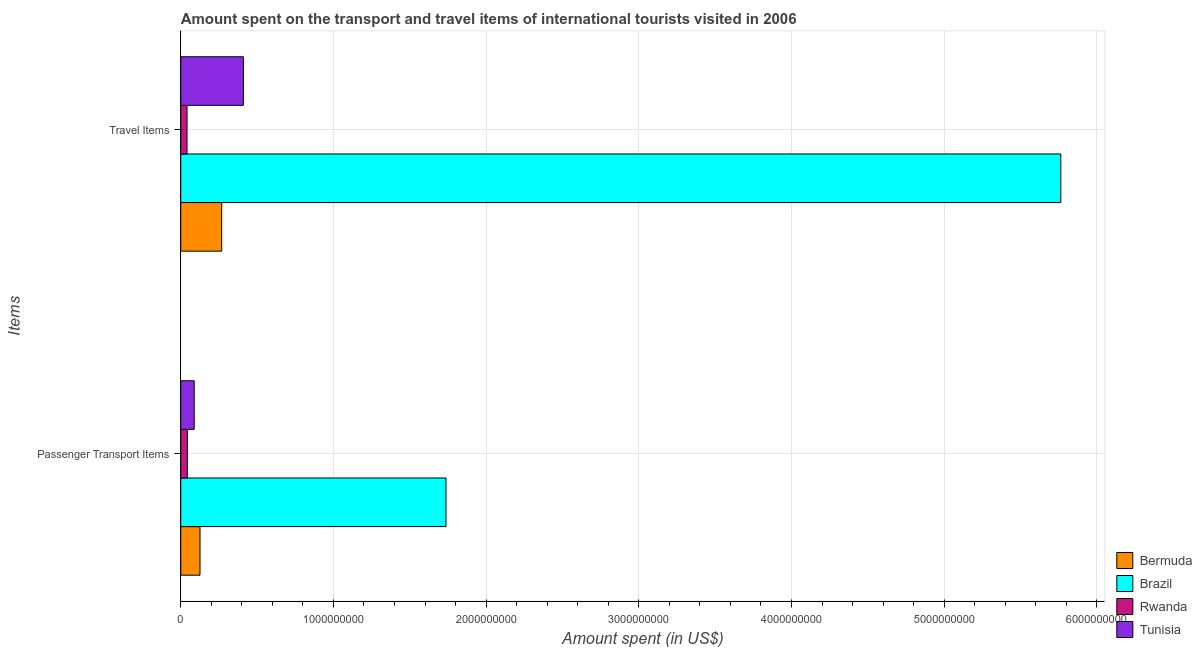How many different coloured bars are there?
Keep it short and to the point. 4. Are the number of bars per tick equal to the number of legend labels?
Give a very brief answer. Yes. Are the number of bars on each tick of the Y-axis equal?
Your answer should be compact. Yes. How many bars are there on the 1st tick from the top?
Ensure brevity in your answer.  4. What is the label of the 2nd group of bars from the top?
Provide a short and direct response. Passenger Transport Items. What is the amount spent in travel items in Bermuda?
Your answer should be compact. 2.68e+08. Across all countries, what is the maximum amount spent in travel items?
Keep it short and to the point. 5.76e+09. Across all countries, what is the minimum amount spent on passenger transport items?
Your answer should be compact. 4.30e+07. In which country was the amount spent on passenger transport items maximum?
Ensure brevity in your answer.  Brazil. In which country was the amount spent on passenger transport items minimum?
Make the answer very short. Rwanda. What is the total amount spent in travel items in the graph?
Offer a terse response. 6.48e+09. What is the difference between the amount spent on passenger transport items in Brazil and that in Rwanda?
Your answer should be very brief. 1.69e+09. What is the difference between the amount spent on passenger transport items in Tunisia and the amount spent in travel items in Brazil?
Provide a short and direct response. -5.68e+09. What is the average amount spent in travel items per country?
Your answer should be very brief. 1.62e+09. What is the difference between the amount spent on passenger transport items and amount spent in travel items in Rwanda?
Offer a terse response. 2.00e+06. What is the ratio of the amount spent in travel items in Bermuda to that in Brazil?
Keep it short and to the point. 0.05. In how many countries, is the amount spent on passenger transport items greater than the average amount spent on passenger transport items taken over all countries?
Offer a terse response. 1. What does the 4th bar from the top in Travel Items represents?
Make the answer very short. Bermuda. What does the 4th bar from the bottom in Travel Items represents?
Your answer should be compact. Tunisia. How many bars are there?
Provide a short and direct response. 8. Are the values on the major ticks of X-axis written in scientific E-notation?
Keep it short and to the point. No. Does the graph contain grids?
Provide a succinct answer. Yes. Where does the legend appear in the graph?
Offer a terse response. Bottom right. How many legend labels are there?
Provide a succinct answer. 4. What is the title of the graph?
Give a very brief answer. Amount spent on the transport and travel items of international tourists visited in 2006. Does "Montenegro" appear as one of the legend labels in the graph?
Make the answer very short. No. What is the label or title of the X-axis?
Ensure brevity in your answer.  Amount spent (in US$). What is the label or title of the Y-axis?
Ensure brevity in your answer.  Items. What is the Amount spent (in US$) of Bermuda in Passenger Transport Items?
Your response must be concise. 1.26e+08. What is the Amount spent (in US$) in Brazil in Passenger Transport Items?
Your response must be concise. 1.74e+09. What is the Amount spent (in US$) of Rwanda in Passenger Transport Items?
Provide a short and direct response. 4.30e+07. What is the Amount spent (in US$) in Tunisia in Passenger Transport Items?
Keep it short and to the point. 8.80e+07. What is the Amount spent (in US$) in Bermuda in Travel Items?
Provide a short and direct response. 2.68e+08. What is the Amount spent (in US$) in Brazil in Travel Items?
Ensure brevity in your answer.  5.76e+09. What is the Amount spent (in US$) of Rwanda in Travel Items?
Provide a succinct answer. 4.10e+07. What is the Amount spent (in US$) of Tunisia in Travel Items?
Your response must be concise. 4.10e+08. Across all Items, what is the maximum Amount spent (in US$) in Bermuda?
Ensure brevity in your answer.  2.68e+08. Across all Items, what is the maximum Amount spent (in US$) in Brazil?
Provide a short and direct response. 5.76e+09. Across all Items, what is the maximum Amount spent (in US$) in Rwanda?
Keep it short and to the point. 4.30e+07. Across all Items, what is the maximum Amount spent (in US$) of Tunisia?
Give a very brief answer. 4.10e+08. Across all Items, what is the minimum Amount spent (in US$) in Bermuda?
Offer a terse response. 1.26e+08. Across all Items, what is the minimum Amount spent (in US$) in Brazil?
Ensure brevity in your answer.  1.74e+09. Across all Items, what is the minimum Amount spent (in US$) of Rwanda?
Offer a terse response. 4.10e+07. Across all Items, what is the minimum Amount spent (in US$) of Tunisia?
Give a very brief answer. 8.80e+07. What is the total Amount spent (in US$) in Bermuda in the graph?
Your answer should be compact. 3.94e+08. What is the total Amount spent (in US$) of Brazil in the graph?
Offer a very short reply. 7.50e+09. What is the total Amount spent (in US$) of Rwanda in the graph?
Your answer should be very brief. 8.40e+07. What is the total Amount spent (in US$) of Tunisia in the graph?
Provide a succinct answer. 4.98e+08. What is the difference between the Amount spent (in US$) of Bermuda in Passenger Transport Items and that in Travel Items?
Your answer should be compact. -1.42e+08. What is the difference between the Amount spent (in US$) in Brazil in Passenger Transport Items and that in Travel Items?
Your answer should be very brief. -4.03e+09. What is the difference between the Amount spent (in US$) in Tunisia in Passenger Transport Items and that in Travel Items?
Provide a succinct answer. -3.22e+08. What is the difference between the Amount spent (in US$) in Bermuda in Passenger Transport Items and the Amount spent (in US$) in Brazil in Travel Items?
Keep it short and to the point. -5.64e+09. What is the difference between the Amount spent (in US$) in Bermuda in Passenger Transport Items and the Amount spent (in US$) in Rwanda in Travel Items?
Your answer should be very brief. 8.50e+07. What is the difference between the Amount spent (in US$) of Bermuda in Passenger Transport Items and the Amount spent (in US$) of Tunisia in Travel Items?
Ensure brevity in your answer.  -2.84e+08. What is the difference between the Amount spent (in US$) of Brazil in Passenger Transport Items and the Amount spent (in US$) of Rwanda in Travel Items?
Keep it short and to the point. 1.70e+09. What is the difference between the Amount spent (in US$) in Brazil in Passenger Transport Items and the Amount spent (in US$) in Tunisia in Travel Items?
Ensure brevity in your answer.  1.33e+09. What is the difference between the Amount spent (in US$) in Rwanda in Passenger Transport Items and the Amount spent (in US$) in Tunisia in Travel Items?
Provide a succinct answer. -3.67e+08. What is the average Amount spent (in US$) in Bermuda per Items?
Ensure brevity in your answer.  1.97e+08. What is the average Amount spent (in US$) in Brazil per Items?
Give a very brief answer. 3.75e+09. What is the average Amount spent (in US$) in Rwanda per Items?
Keep it short and to the point. 4.20e+07. What is the average Amount spent (in US$) of Tunisia per Items?
Keep it short and to the point. 2.49e+08. What is the difference between the Amount spent (in US$) in Bermuda and Amount spent (in US$) in Brazil in Passenger Transport Items?
Your response must be concise. -1.61e+09. What is the difference between the Amount spent (in US$) of Bermuda and Amount spent (in US$) of Rwanda in Passenger Transport Items?
Make the answer very short. 8.30e+07. What is the difference between the Amount spent (in US$) in Bermuda and Amount spent (in US$) in Tunisia in Passenger Transport Items?
Keep it short and to the point. 3.80e+07. What is the difference between the Amount spent (in US$) in Brazil and Amount spent (in US$) in Rwanda in Passenger Transport Items?
Your answer should be very brief. 1.69e+09. What is the difference between the Amount spent (in US$) in Brazil and Amount spent (in US$) in Tunisia in Passenger Transport Items?
Offer a very short reply. 1.65e+09. What is the difference between the Amount spent (in US$) in Rwanda and Amount spent (in US$) in Tunisia in Passenger Transport Items?
Offer a terse response. -4.50e+07. What is the difference between the Amount spent (in US$) in Bermuda and Amount spent (in US$) in Brazil in Travel Items?
Your answer should be very brief. -5.50e+09. What is the difference between the Amount spent (in US$) in Bermuda and Amount spent (in US$) in Rwanda in Travel Items?
Your answer should be compact. 2.27e+08. What is the difference between the Amount spent (in US$) in Bermuda and Amount spent (in US$) in Tunisia in Travel Items?
Give a very brief answer. -1.42e+08. What is the difference between the Amount spent (in US$) of Brazil and Amount spent (in US$) of Rwanda in Travel Items?
Offer a terse response. 5.72e+09. What is the difference between the Amount spent (in US$) of Brazil and Amount spent (in US$) of Tunisia in Travel Items?
Keep it short and to the point. 5.35e+09. What is the difference between the Amount spent (in US$) in Rwanda and Amount spent (in US$) in Tunisia in Travel Items?
Your answer should be very brief. -3.69e+08. What is the ratio of the Amount spent (in US$) in Bermuda in Passenger Transport Items to that in Travel Items?
Ensure brevity in your answer.  0.47. What is the ratio of the Amount spent (in US$) of Brazil in Passenger Transport Items to that in Travel Items?
Offer a terse response. 0.3. What is the ratio of the Amount spent (in US$) in Rwanda in Passenger Transport Items to that in Travel Items?
Offer a terse response. 1.05. What is the ratio of the Amount spent (in US$) of Tunisia in Passenger Transport Items to that in Travel Items?
Your answer should be compact. 0.21. What is the difference between the highest and the second highest Amount spent (in US$) of Bermuda?
Provide a short and direct response. 1.42e+08. What is the difference between the highest and the second highest Amount spent (in US$) of Brazil?
Offer a terse response. 4.03e+09. What is the difference between the highest and the second highest Amount spent (in US$) in Rwanda?
Offer a terse response. 2.00e+06. What is the difference between the highest and the second highest Amount spent (in US$) of Tunisia?
Offer a terse response. 3.22e+08. What is the difference between the highest and the lowest Amount spent (in US$) in Bermuda?
Make the answer very short. 1.42e+08. What is the difference between the highest and the lowest Amount spent (in US$) of Brazil?
Offer a very short reply. 4.03e+09. What is the difference between the highest and the lowest Amount spent (in US$) in Tunisia?
Your answer should be compact. 3.22e+08. 